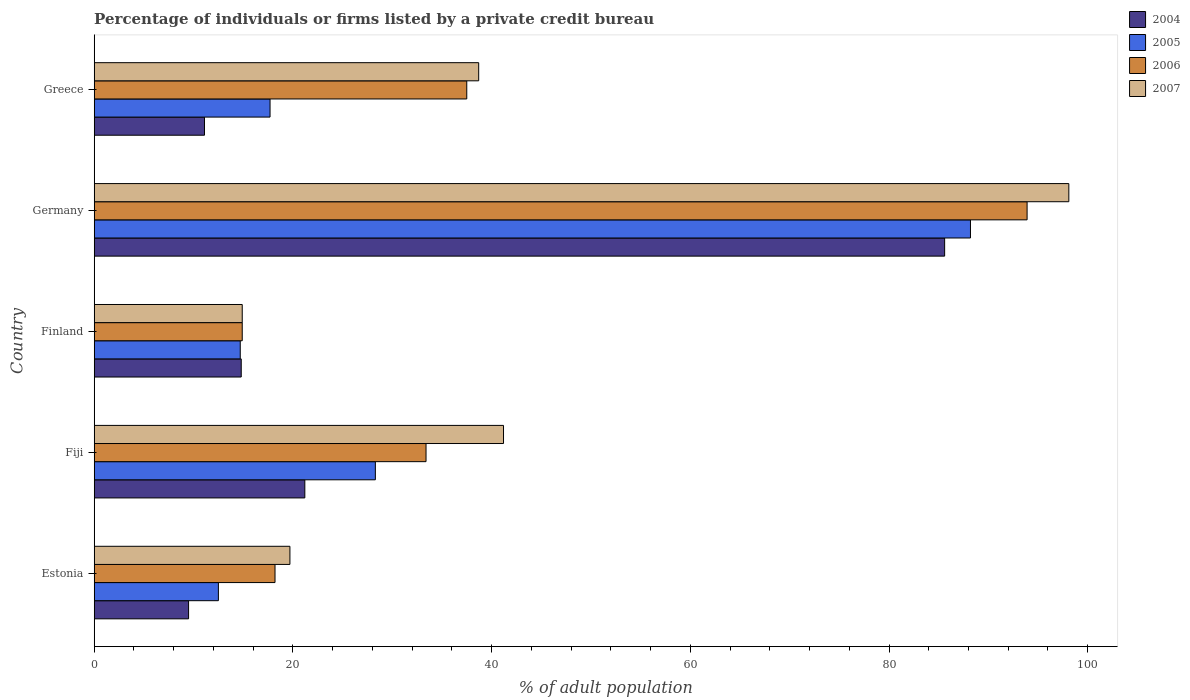How many groups of bars are there?
Keep it short and to the point. 5. Are the number of bars per tick equal to the number of legend labels?
Your answer should be compact. Yes. How many bars are there on the 3rd tick from the top?
Keep it short and to the point. 4. What is the label of the 4th group of bars from the top?
Keep it short and to the point. Fiji. In how many cases, is the number of bars for a given country not equal to the number of legend labels?
Offer a terse response. 0. Across all countries, what is the maximum percentage of population listed by a private credit bureau in 2006?
Your answer should be compact. 93.9. In which country was the percentage of population listed by a private credit bureau in 2007 minimum?
Ensure brevity in your answer.  Finland. What is the total percentage of population listed by a private credit bureau in 2006 in the graph?
Make the answer very short. 197.9. What is the difference between the percentage of population listed by a private credit bureau in 2005 in Estonia and that in Finland?
Provide a succinct answer. -2.2. What is the difference between the percentage of population listed by a private credit bureau in 2005 in Greece and the percentage of population listed by a private credit bureau in 2004 in Germany?
Your answer should be compact. -67.9. What is the average percentage of population listed by a private credit bureau in 2007 per country?
Offer a very short reply. 42.52. What is the difference between the percentage of population listed by a private credit bureau in 2007 and percentage of population listed by a private credit bureau in 2006 in Germany?
Your answer should be compact. 4.2. What is the ratio of the percentage of population listed by a private credit bureau in 2006 in Fiji to that in Germany?
Ensure brevity in your answer.  0.36. What is the difference between the highest and the second highest percentage of population listed by a private credit bureau in 2007?
Offer a terse response. 56.9. What is the difference between the highest and the lowest percentage of population listed by a private credit bureau in 2007?
Ensure brevity in your answer.  83.2. In how many countries, is the percentage of population listed by a private credit bureau in 2006 greater than the average percentage of population listed by a private credit bureau in 2006 taken over all countries?
Offer a terse response. 1. What does the 2nd bar from the top in Germany represents?
Ensure brevity in your answer.  2006. Is it the case that in every country, the sum of the percentage of population listed by a private credit bureau in 2005 and percentage of population listed by a private credit bureau in 2004 is greater than the percentage of population listed by a private credit bureau in 2006?
Offer a terse response. No. Are all the bars in the graph horizontal?
Your answer should be very brief. Yes. Does the graph contain grids?
Provide a short and direct response. No. Where does the legend appear in the graph?
Offer a terse response. Top right. What is the title of the graph?
Give a very brief answer. Percentage of individuals or firms listed by a private credit bureau. What is the label or title of the X-axis?
Ensure brevity in your answer.  % of adult population. What is the label or title of the Y-axis?
Make the answer very short. Country. What is the % of adult population in 2004 in Estonia?
Give a very brief answer. 9.5. What is the % of adult population of 2005 in Estonia?
Keep it short and to the point. 12.5. What is the % of adult population of 2006 in Estonia?
Your response must be concise. 18.2. What is the % of adult population in 2004 in Fiji?
Your response must be concise. 21.2. What is the % of adult population in 2005 in Fiji?
Keep it short and to the point. 28.3. What is the % of adult population in 2006 in Fiji?
Provide a succinct answer. 33.4. What is the % of adult population in 2007 in Fiji?
Offer a terse response. 41.2. What is the % of adult population of 2004 in Finland?
Give a very brief answer. 14.8. What is the % of adult population in 2005 in Finland?
Offer a very short reply. 14.7. What is the % of adult population of 2006 in Finland?
Offer a very short reply. 14.9. What is the % of adult population in 2004 in Germany?
Your answer should be very brief. 85.6. What is the % of adult population in 2005 in Germany?
Provide a succinct answer. 88.2. What is the % of adult population in 2006 in Germany?
Provide a succinct answer. 93.9. What is the % of adult population of 2007 in Germany?
Ensure brevity in your answer.  98.1. What is the % of adult population in 2004 in Greece?
Provide a short and direct response. 11.1. What is the % of adult population of 2005 in Greece?
Offer a very short reply. 17.7. What is the % of adult population in 2006 in Greece?
Provide a short and direct response. 37.5. What is the % of adult population of 2007 in Greece?
Your response must be concise. 38.7. Across all countries, what is the maximum % of adult population in 2004?
Offer a terse response. 85.6. Across all countries, what is the maximum % of adult population of 2005?
Keep it short and to the point. 88.2. Across all countries, what is the maximum % of adult population of 2006?
Make the answer very short. 93.9. Across all countries, what is the maximum % of adult population of 2007?
Offer a terse response. 98.1. Across all countries, what is the minimum % of adult population in 2004?
Provide a succinct answer. 9.5. Across all countries, what is the minimum % of adult population of 2006?
Offer a very short reply. 14.9. What is the total % of adult population in 2004 in the graph?
Ensure brevity in your answer.  142.2. What is the total % of adult population of 2005 in the graph?
Your response must be concise. 161.4. What is the total % of adult population of 2006 in the graph?
Your answer should be compact. 197.9. What is the total % of adult population of 2007 in the graph?
Your answer should be very brief. 212.6. What is the difference between the % of adult population in 2004 in Estonia and that in Fiji?
Provide a short and direct response. -11.7. What is the difference between the % of adult population of 2005 in Estonia and that in Fiji?
Provide a short and direct response. -15.8. What is the difference between the % of adult population of 2006 in Estonia and that in Fiji?
Offer a terse response. -15.2. What is the difference between the % of adult population in 2007 in Estonia and that in Fiji?
Your answer should be very brief. -21.5. What is the difference between the % of adult population of 2006 in Estonia and that in Finland?
Offer a very short reply. 3.3. What is the difference between the % of adult population of 2004 in Estonia and that in Germany?
Offer a terse response. -76.1. What is the difference between the % of adult population in 2005 in Estonia and that in Germany?
Your answer should be compact. -75.7. What is the difference between the % of adult population in 2006 in Estonia and that in Germany?
Give a very brief answer. -75.7. What is the difference between the % of adult population of 2007 in Estonia and that in Germany?
Offer a terse response. -78.4. What is the difference between the % of adult population in 2006 in Estonia and that in Greece?
Ensure brevity in your answer.  -19.3. What is the difference between the % of adult population of 2004 in Fiji and that in Finland?
Offer a terse response. 6.4. What is the difference between the % of adult population in 2006 in Fiji and that in Finland?
Provide a short and direct response. 18.5. What is the difference between the % of adult population of 2007 in Fiji and that in Finland?
Provide a short and direct response. 26.3. What is the difference between the % of adult population in 2004 in Fiji and that in Germany?
Your response must be concise. -64.4. What is the difference between the % of adult population in 2005 in Fiji and that in Germany?
Your response must be concise. -59.9. What is the difference between the % of adult population in 2006 in Fiji and that in Germany?
Provide a succinct answer. -60.5. What is the difference between the % of adult population of 2007 in Fiji and that in Germany?
Provide a short and direct response. -56.9. What is the difference between the % of adult population in 2004 in Fiji and that in Greece?
Your response must be concise. 10.1. What is the difference between the % of adult population in 2005 in Fiji and that in Greece?
Ensure brevity in your answer.  10.6. What is the difference between the % of adult population of 2006 in Fiji and that in Greece?
Make the answer very short. -4.1. What is the difference between the % of adult population of 2004 in Finland and that in Germany?
Provide a succinct answer. -70.8. What is the difference between the % of adult population of 2005 in Finland and that in Germany?
Ensure brevity in your answer.  -73.5. What is the difference between the % of adult population of 2006 in Finland and that in Germany?
Keep it short and to the point. -79. What is the difference between the % of adult population in 2007 in Finland and that in Germany?
Give a very brief answer. -83.2. What is the difference between the % of adult population of 2006 in Finland and that in Greece?
Keep it short and to the point. -22.6. What is the difference between the % of adult population in 2007 in Finland and that in Greece?
Give a very brief answer. -23.8. What is the difference between the % of adult population in 2004 in Germany and that in Greece?
Provide a short and direct response. 74.5. What is the difference between the % of adult population in 2005 in Germany and that in Greece?
Offer a very short reply. 70.5. What is the difference between the % of adult population in 2006 in Germany and that in Greece?
Your answer should be very brief. 56.4. What is the difference between the % of adult population of 2007 in Germany and that in Greece?
Give a very brief answer. 59.4. What is the difference between the % of adult population in 2004 in Estonia and the % of adult population in 2005 in Fiji?
Offer a very short reply. -18.8. What is the difference between the % of adult population in 2004 in Estonia and the % of adult population in 2006 in Fiji?
Your answer should be very brief. -23.9. What is the difference between the % of adult population in 2004 in Estonia and the % of adult population in 2007 in Fiji?
Provide a short and direct response. -31.7. What is the difference between the % of adult population in 2005 in Estonia and the % of adult population in 2006 in Fiji?
Make the answer very short. -20.9. What is the difference between the % of adult population of 2005 in Estonia and the % of adult population of 2007 in Fiji?
Ensure brevity in your answer.  -28.7. What is the difference between the % of adult population of 2004 in Estonia and the % of adult population of 2006 in Finland?
Give a very brief answer. -5.4. What is the difference between the % of adult population in 2004 in Estonia and the % of adult population in 2007 in Finland?
Make the answer very short. -5.4. What is the difference between the % of adult population of 2005 in Estonia and the % of adult population of 2006 in Finland?
Give a very brief answer. -2.4. What is the difference between the % of adult population in 2004 in Estonia and the % of adult population in 2005 in Germany?
Provide a short and direct response. -78.7. What is the difference between the % of adult population of 2004 in Estonia and the % of adult population of 2006 in Germany?
Make the answer very short. -84.4. What is the difference between the % of adult population of 2004 in Estonia and the % of adult population of 2007 in Germany?
Provide a succinct answer. -88.6. What is the difference between the % of adult population in 2005 in Estonia and the % of adult population in 2006 in Germany?
Offer a terse response. -81.4. What is the difference between the % of adult population of 2005 in Estonia and the % of adult population of 2007 in Germany?
Give a very brief answer. -85.6. What is the difference between the % of adult population of 2006 in Estonia and the % of adult population of 2007 in Germany?
Offer a very short reply. -79.9. What is the difference between the % of adult population of 2004 in Estonia and the % of adult population of 2006 in Greece?
Offer a terse response. -28. What is the difference between the % of adult population of 2004 in Estonia and the % of adult population of 2007 in Greece?
Your answer should be very brief. -29.2. What is the difference between the % of adult population of 2005 in Estonia and the % of adult population of 2006 in Greece?
Give a very brief answer. -25. What is the difference between the % of adult population in 2005 in Estonia and the % of adult population in 2007 in Greece?
Give a very brief answer. -26.2. What is the difference between the % of adult population in 2006 in Estonia and the % of adult population in 2007 in Greece?
Provide a short and direct response. -20.5. What is the difference between the % of adult population in 2004 in Fiji and the % of adult population in 2005 in Finland?
Your answer should be very brief. 6.5. What is the difference between the % of adult population of 2004 in Fiji and the % of adult population of 2007 in Finland?
Offer a very short reply. 6.3. What is the difference between the % of adult population in 2004 in Fiji and the % of adult population in 2005 in Germany?
Your answer should be very brief. -67. What is the difference between the % of adult population in 2004 in Fiji and the % of adult population in 2006 in Germany?
Your response must be concise. -72.7. What is the difference between the % of adult population in 2004 in Fiji and the % of adult population in 2007 in Germany?
Provide a succinct answer. -76.9. What is the difference between the % of adult population in 2005 in Fiji and the % of adult population in 2006 in Germany?
Ensure brevity in your answer.  -65.6. What is the difference between the % of adult population in 2005 in Fiji and the % of adult population in 2007 in Germany?
Keep it short and to the point. -69.8. What is the difference between the % of adult population in 2006 in Fiji and the % of adult population in 2007 in Germany?
Offer a terse response. -64.7. What is the difference between the % of adult population of 2004 in Fiji and the % of adult population of 2005 in Greece?
Make the answer very short. 3.5. What is the difference between the % of adult population in 2004 in Fiji and the % of adult population in 2006 in Greece?
Your answer should be compact. -16.3. What is the difference between the % of adult population in 2004 in Fiji and the % of adult population in 2007 in Greece?
Keep it short and to the point. -17.5. What is the difference between the % of adult population in 2004 in Finland and the % of adult population in 2005 in Germany?
Give a very brief answer. -73.4. What is the difference between the % of adult population of 2004 in Finland and the % of adult population of 2006 in Germany?
Keep it short and to the point. -79.1. What is the difference between the % of adult population in 2004 in Finland and the % of adult population in 2007 in Germany?
Your response must be concise. -83.3. What is the difference between the % of adult population of 2005 in Finland and the % of adult population of 2006 in Germany?
Keep it short and to the point. -79.2. What is the difference between the % of adult population in 2005 in Finland and the % of adult population in 2007 in Germany?
Your response must be concise. -83.4. What is the difference between the % of adult population in 2006 in Finland and the % of adult population in 2007 in Germany?
Keep it short and to the point. -83.2. What is the difference between the % of adult population of 2004 in Finland and the % of adult population of 2006 in Greece?
Provide a succinct answer. -22.7. What is the difference between the % of adult population of 2004 in Finland and the % of adult population of 2007 in Greece?
Offer a terse response. -23.9. What is the difference between the % of adult population of 2005 in Finland and the % of adult population of 2006 in Greece?
Provide a succinct answer. -22.8. What is the difference between the % of adult population of 2006 in Finland and the % of adult population of 2007 in Greece?
Provide a short and direct response. -23.8. What is the difference between the % of adult population in 2004 in Germany and the % of adult population in 2005 in Greece?
Make the answer very short. 67.9. What is the difference between the % of adult population in 2004 in Germany and the % of adult population in 2006 in Greece?
Provide a succinct answer. 48.1. What is the difference between the % of adult population of 2004 in Germany and the % of adult population of 2007 in Greece?
Offer a very short reply. 46.9. What is the difference between the % of adult population in 2005 in Germany and the % of adult population in 2006 in Greece?
Give a very brief answer. 50.7. What is the difference between the % of adult population in 2005 in Germany and the % of adult population in 2007 in Greece?
Your answer should be compact. 49.5. What is the difference between the % of adult population of 2006 in Germany and the % of adult population of 2007 in Greece?
Offer a terse response. 55.2. What is the average % of adult population in 2004 per country?
Make the answer very short. 28.44. What is the average % of adult population of 2005 per country?
Make the answer very short. 32.28. What is the average % of adult population of 2006 per country?
Provide a short and direct response. 39.58. What is the average % of adult population in 2007 per country?
Your answer should be very brief. 42.52. What is the difference between the % of adult population of 2005 and % of adult population of 2006 in Estonia?
Ensure brevity in your answer.  -5.7. What is the difference between the % of adult population in 2005 and % of adult population in 2007 in Estonia?
Offer a very short reply. -7.2. What is the difference between the % of adult population of 2006 and % of adult population of 2007 in Estonia?
Your answer should be very brief. -1.5. What is the difference between the % of adult population in 2004 and % of adult population in 2006 in Fiji?
Your response must be concise. -12.2. What is the difference between the % of adult population in 2006 and % of adult population in 2007 in Fiji?
Give a very brief answer. -7.8. What is the difference between the % of adult population of 2004 and % of adult population of 2005 in Finland?
Offer a terse response. 0.1. What is the difference between the % of adult population of 2004 and % of adult population of 2006 in Finland?
Ensure brevity in your answer.  -0.1. What is the difference between the % of adult population of 2004 and % of adult population of 2007 in Finland?
Provide a succinct answer. -0.1. What is the difference between the % of adult population of 2005 and % of adult population of 2006 in Finland?
Offer a very short reply. -0.2. What is the difference between the % of adult population of 2004 and % of adult population of 2006 in Germany?
Offer a very short reply. -8.3. What is the difference between the % of adult population in 2005 and % of adult population in 2007 in Germany?
Ensure brevity in your answer.  -9.9. What is the difference between the % of adult population of 2006 and % of adult population of 2007 in Germany?
Your answer should be very brief. -4.2. What is the difference between the % of adult population of 2004 and % of adult population of 2006 in Greece?
Your answer should be very brief. -26.4. What is the difference between the % of adult population in 2004 and % of adult population in 2007 in Greece?
Your response must be concise. -27.6. What is the difference between the % of adult population in 2005 and % of adult population in 2006 in Greece?
Make the answer very short. -19.8. What is the difference between the % of adult population of 2005 and % of adult population of 2007 in Greece?
Give a very brief answer. -21. What is the ratio of the % of adult population of 2004 in Estonia to that in Fiji?
Ensure brevity in your answer.  0.45. What is the ratio of the % of adult population in 2005 in Estonia to that in Fiji?
Offer a terse response. 0.44. What is the ratio of the % of adult population of 2006 in Estonia to that in Fiji?
Offer a terse response. 0.54. What is the ratio of the % of adult population of 2007 in Estonia to that in Fiji?
Give a very brief answer. 0.48. What is the ratio of the % of adult population in 2004 in Estonia to that in Finland?
Offer a very short reply. 0.64. What is the ratio of the % of adult population of 2005 in Estonia to that in Finland?
Provide a short and direct response. 0.85. What is the ratio of the % of adult population in 2006 in Estonia to that in Finland?
Your answer should be very brief. 1.22. What is the ratio of the % of adult population in 2007 in Estonia to that in Finland?
Your response must be concise. 1.32. What is the ratio of the % of adult population of 2004 in Estonia to that in Germany?
Ensure brevity in your answer.  0.11. What is the ratio of the % of adult population of 2005 in Estonia to that in Germany?
Provide a succinct answer. 0.14. What is the ratio of the % of adult population in 2006 in Estonia to that in Germany?
Provide a succinct answer. 0.19. What is the ratio of the % of adult population of 2007 in Estonia to that in Germany?
Your answer should be very brief. 0.2. What is the ratio of the % of adult population in 2004 in Estonia to that in Greece?
Provide a short and direct response. 0.86. What is the ratio of the % of adult population in 2005 in Estonia to that in Greece?
Offer a very short reply. 0.71. What is the ratio of the % of adult population in 2006 in Estonia to that in Greece?
Your answer should be compact. 0.49. What is the ratio of the % of adult population in 2007 in Estonia to that in Greece?
Your answer should be compact. 0.51. What is the ratio of the % of adult population of 2004 in Fiji to that in Finland?
Your answer should be compact. 1.43. What is the ratio of the % of adult population of 2005 in Fiji to that in Finland?
Your response must be concise. 1.93. What is the ratio of the % of adult population of 2006 in Fiji to that in Finland?
Your answer should be very brief. 2.24. What is the ratio of the % of adult population in 2007 in Fiji to that in Finland?
Your answer should be very brief. 2.77. What is the ratio of the % of adult population in 2004 in Fiji to that in Germany?
Your answer should be compact. 0.25. What is the ratio of the % of adult population in 2005 in Fiji to that in Germany?
Your answer should be very brief. 0.32. What is the ratio of the % of adult population of 2006 in Fiji to that in Germany?
Provide a short and direct response. 0.36. What is the ratio of the % of adult population of 2007 in Fiji to that in Germany?
Your answer should be compact. 0.42. What is the ratio of the % of adult population of 2004 in Fiji to that in Greece?
Your answer should be very brief. 1.91. What is the ratio of the % of adult population of 2005 in Fiji to that in Greece?
Provide a succinct answer. 1.6. What is the ratio of the % of adult population in 2006 in Fiji to that in Greece?
Your answer should be compact. 0.89. What is the ratio of the % of adult population of 2007 in Fiji to that in Greece?
Keep it short and to the point. 1.06. What is the ratio of the % of adult population in 2004 in Finland to that in Germany?
Ensure brevity in your answer.  0.17. What is the ratio of the % of adult population in 2005 in Finland to that in Germany?
Your answer should be very brief. 0.17. What is the ratio of the % of adult population of 2006 in Finland to that in Germany?
Provide a short and direct response. 0.16. What is the ratio of the % of adult population of 2007 in Finland to that in Germany?
Make the answer very short. 0.15. What is the ratio of the % of adult population of 2004 in Finland to that in Greece?
Offer a very short reply. 1.33. What is the ratio of the % of adult population of 2005 in Finland to that in Greece?
Your answer should be very brief. 0.83. What is the ratio of the % of adult population in 2006 in Finland to that in Greece?
Your answer should be compact. 0.4. What is the ratio of the % of adult population of 2007 in Finland to that in Greece?
Ensure brevity in your answer.  0.39. What is the ratio of the % of adult population in 2004 in Germany to that in Greece?
Make the answer very short. 7.71. What is the ratio of the % of adult population of 2005 in Germany to that in Greece?
Offer a very short reply. 4.98. What is the ratio of the % of adult population of 2006 in Germany to that in Greece?
Ensure brevity in your answer.  2.5. What is the ratio of the % of adult population of 2007 in Germany to that in Greece?
Offer a very short reply. 2.53. What is the difference between the highest and the second highest % of adult population of 2004?
Make the answer very short. 64.4. What is the difference between the highest and the second highest % of adult population in 2005?
Make the answer very short. 59.9. What is the difference between the highest and the second highest % of adult population of 2006?
Your answer should be compact. 56.4. What is the difference between the highest and the second highest % of adult population of 2007?
Your answer should be very brief. 56.9. What is the difference between the highest and the lowest % of adult population of 2004?
Your answer should be very brief. 76.1. What is the difference between the highest and the lowest % of adult population of 2005?
Your answer should be compact. 75.7. What is the difference between the highest and the lowest % of adult population of 2006?
Your answer should be very brief. 79. What is the difference between the highest and the lowest % of adult population of 2007?
Keep it short and to the point. 83.2. 